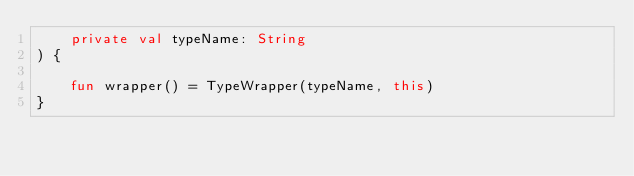Convert code to text. <code><loc_0><loc_0><loc_500><loc_500><_Kotlin_>    private val typeName: String
) {

    fun wrapper() = TypeWrapper(typeName, this)
}</code> 